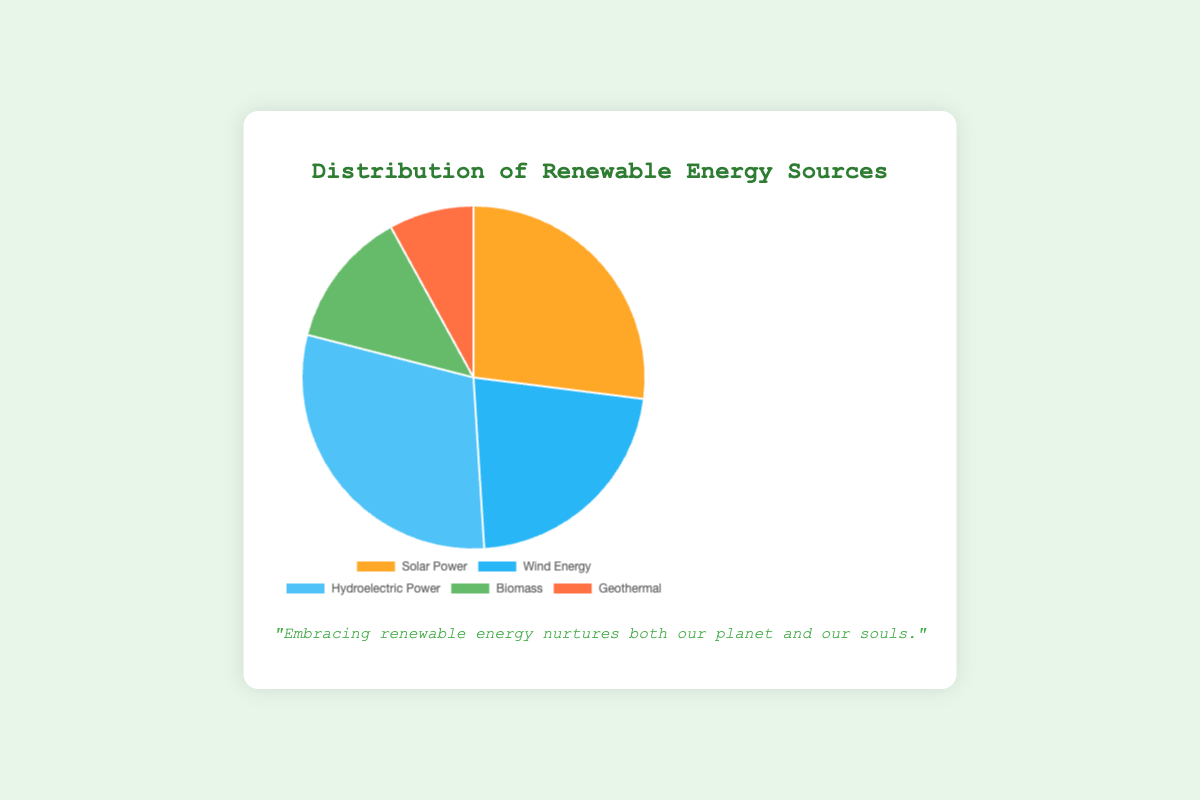What's the largest portion of renewable energy sources in the distribution? The chart shows different renewable energy sources with their respective percentages. The segment with the highest percentage is labeled "Hydroelectric Power" with 30%.
Answer: Hydroelectric Power Which renewable energy source contributes the least to the distribution? By looking at the chart, the smallest segment is labeled "Geothermal" with 8%.
Answer: Geothermal Compare the combined percentage of Solar Power and Wind Energy to Hydroelectric Power. Which is greater? Solar Power is 27% and Wind Energy is 22%, so combined they are 27% + 22% = 49%. Hydroelectric Power is 30%. Since 49% > 30%, the combined percentage of Solar Power and Wind Energy is greater.
Answer: Solar Power and Wind Energy What is the difference in percentage between Biomass and Geothermal energy sources? Biomass is shown as 13% and Geothermal is 8%. The difference is 13% - 8% = 5%.
Answer: 5% If the total distribution sum is 100%, what percentage of the total do the Solar Power and Hydroelectric Power together contribute? Solar Power contributes 27% and Hydroelectric Power contributes 30%. Together, they add up to 27% + 30% = 57%.
Answer: 57% What is the average percentage contribution of all five renewable energy sources? The percentages for all sources are: 27% (Solar Power), 22% (Wind Energy), 30% (Hydroelectric Power), 13% (Biomass), and 8% (Geothermal). Summing these gives 27 + 22 + 30 + 13 + 8 = 100. The average is 100 / 5 = 20%.
Answer: 20% Which color segment represents the Wind Energy percentage? The chart uses different colors for each segment. The Wind Energy segment is colored blue.
Answer: Blue Which renewable energy source almost matches Wind Energy in percentage, and what is their difference? Wind Energy is 22%. Solar Power is closest with 27%. The difference is 27% - 22% = 5%.
Answer: Solar Power, 5% What is the sum of the percentages of the least two contributing renewable energy sources? The least contributing sources are Geothermal (8%) and Biomass (13%). Their sum is 8% + 13% = 21%.
Answer: 21% 